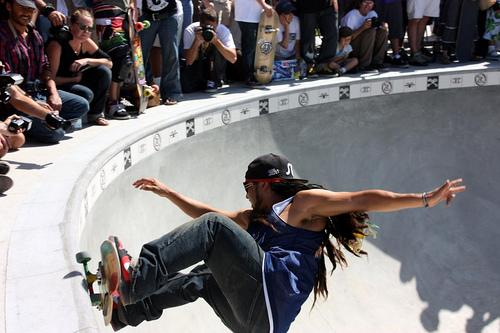What is the person in the foreground doing? Please explain your reasoning. skateboarding. The person is on a plank of wood attached to four wheels. 